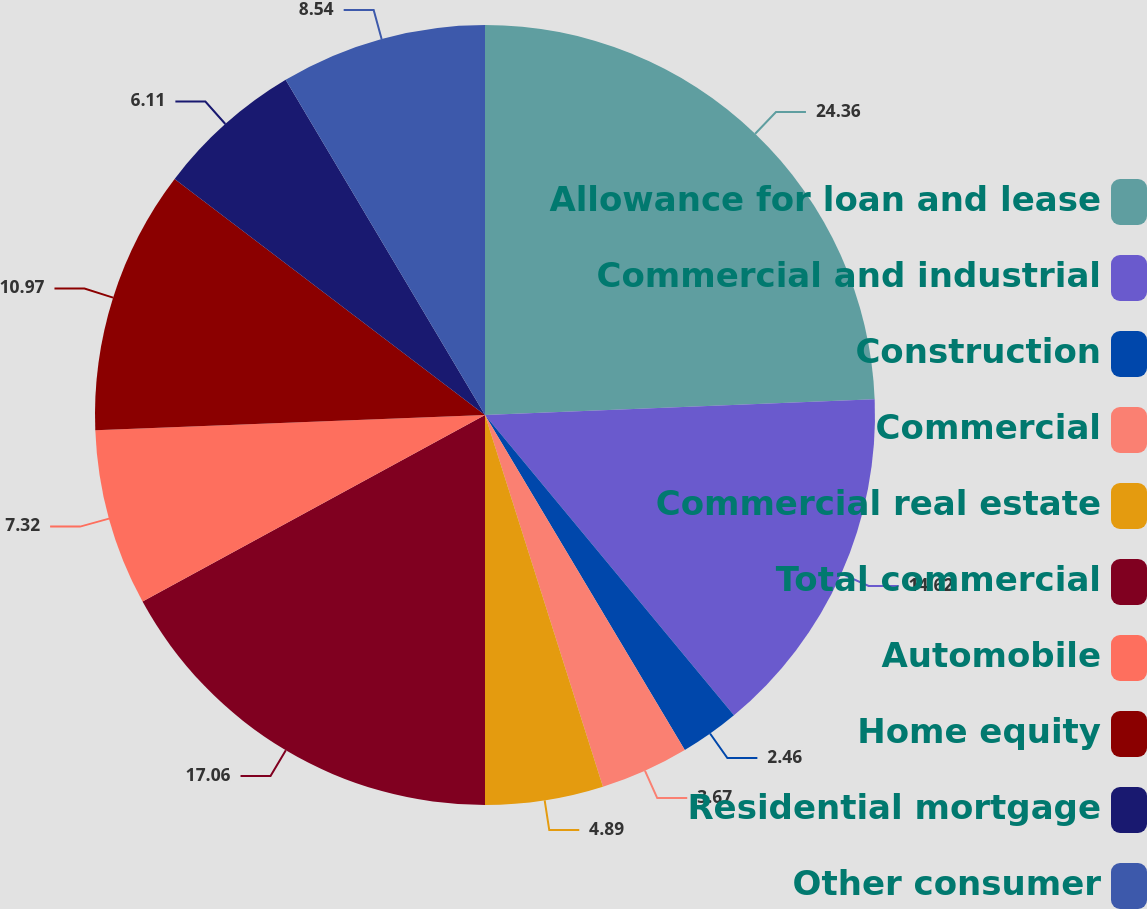Convert chart to OTSL. <chart><loc_0><loc_0><loc_500><loc_500><pie_chart><fcel>Allowance for loan and lease<fcel>Commercial and industrial<fcel>Construction<fcel>Commercial<fcel>Commercial real estate<fcel>Total commercial<fcel>Automobile<fcel>Home equity<fcel>Residential mortgage<fcel>Other consumer<nl><fcel>24.36%<fcel>14.62%<fcel>2.46%<fcel>3.67%<fcel>4.89%<fcel>17.06%<fcel>7.32%<fcel>10.97%<fcel>6.11%<fcel>8.54%<nl></chart> 